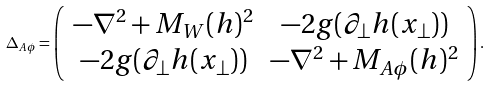Convert formula to latex. <formula><loc_0><loc_0><loc_500><loc_500>\Delta _ { A \phi } = \left ( \begin{array} { c c c } - \nabla ^ { 2 } + M _ { W } ( h ) ^ { 2 } & - 2 g ( \partial _ { \bot } h ( x _ { \bot } ) ) \\ - 2 g ( \partial _ { \bot } h ( x _ { \bot } ) ) & - \nabla ^ { 2 } + M _ { A \phi } ( h ) ^ { 2 } \end{array} \right ) .</formula> 